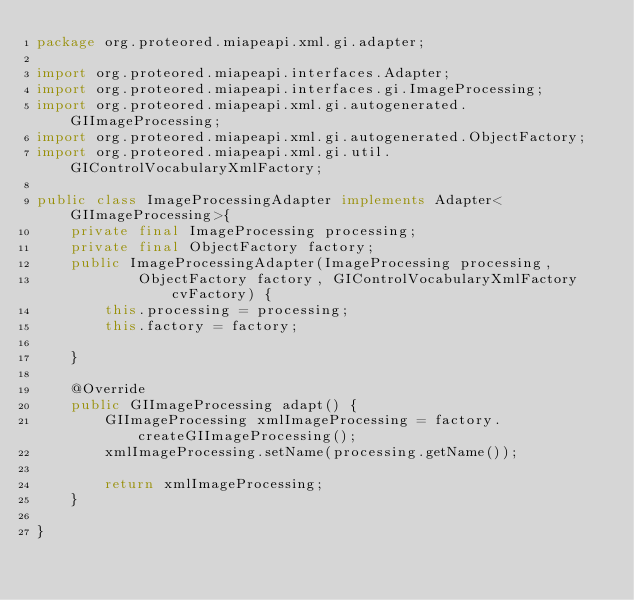<code> <loc_0><loc_0><loc_500><loc_500><_Java_>package org.proteored.miapeapi.xml.gi.adapter;

import org.proteored.miapeapi.interfaces.Adapter;
import org.proteored.miapeapi.interfaces.gi.ImageProcessing;
import org.proteored.miapeapi.xml.gi.autogenerated.GIImageProcessing;
import org.proteored.miapeapi.xml.gi.autogenerated.ObjectFactory;
import org.proteored.miapeapi.xml.gi.util.GIControlVocabularyXmlFactory;

public class ImageProcessingAdapter implements Adapter<GIImageProcessing>{
	private final ImageProcessing processing;
	private final ObjectFactory factory;
	public ImageProcessingAdapter(ImageProcessing processing,
			ObjectFactory factory, GIControlVocabularyXmlFactory cvFactory) {
		this.processing = processing;
		this.factory = factory;

	}

	@Override
	public GIImageProcessing adapt() {
		GIImageProcessing xmlImageProcessing = factory.createGIImageProcessing();
		xmlImageProcessing.setName(processing.getName());

		return xmlImageProcessing;
	}

}
</code> 